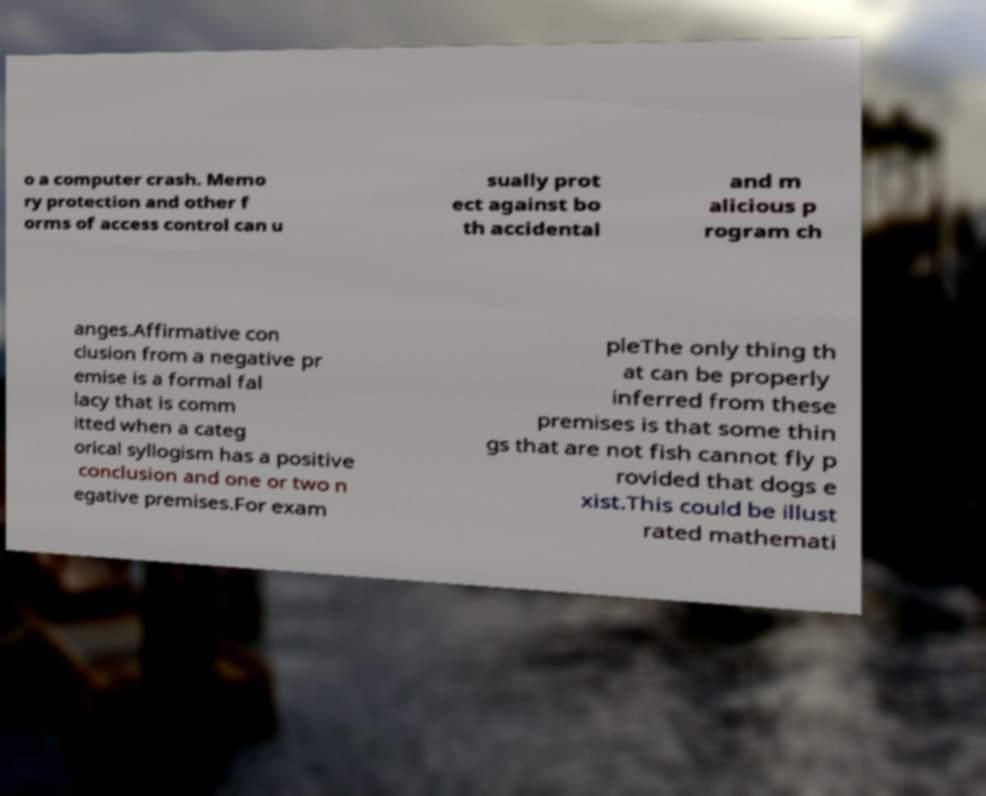For documentation purposes, I need the text within this image transcribed. Could you provide that? o a computer crash. Memo ry protection and other f orms of access control can u sually prot ect against bo th accidental and m alicious p rogram ch anges.Affirmative con clusion from a negative pr emise is a formal fal lacy that is comm itted when a categ orical syllogism has a positive conclusion and one or two n egative premises.For exam pleThe only thing th at can be properly inferred from these premises is that some thin gs that are not fish cannot fly p rovided that dogs e xist.This could be illust rated mathemati 